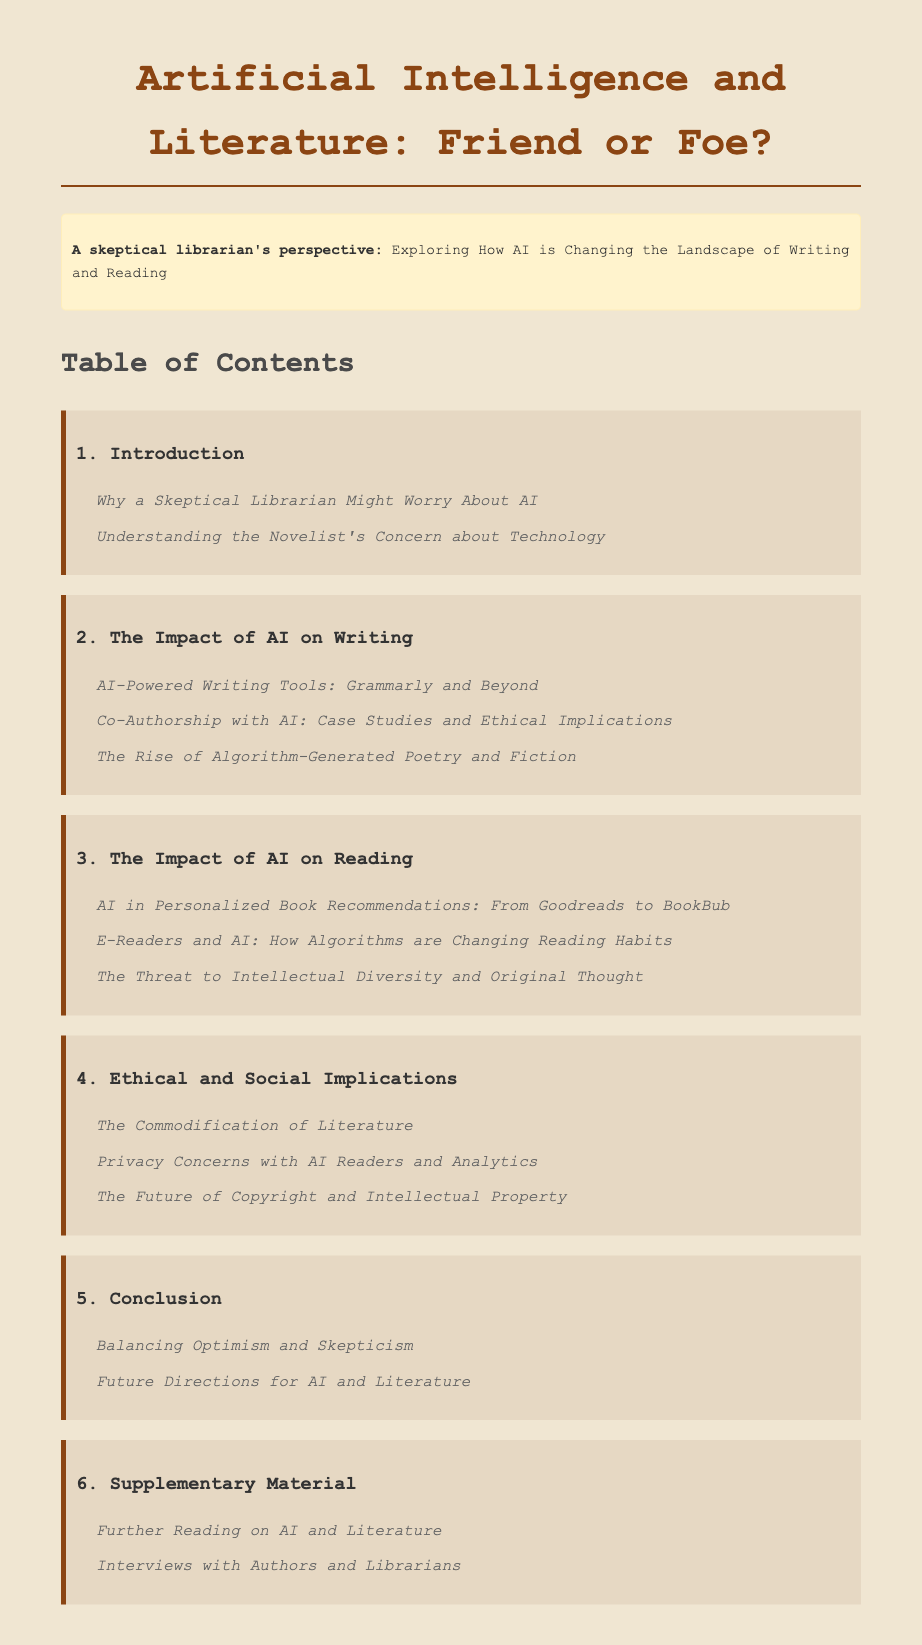What is the title of the document? The title is presented prominently at the top of the document, identifying the main topic.
Answer: Artificial Intelligence and Literature: Friend or Foe? What is the first subchapter listed under "Introduction"? The first subchapter of the first chapter, "Introduction," is explicitly listed after the chapter title.
Answer: Why a Skeptical Librarian Might Worry About AI How many subchapters are under "The Impact of AI on Writing"? The document lists how many topics are discussed under this chapter, which can be counted.
Answer: Three What ethical concern is discussed in the "Ethical and Social Implications" chapter? A specific concern mentioned in the subchapters indicates a broader issue related to literature and AI.
Answer: The Commodification of Literature What chapter discusses the future of copyright? The chapter dedicated to discussing legal implications provides insights into copyright issues related to AI.
Answer: Ethical and Social Implications How many chapters are in the document? The number of chapters is identifiable by counting the main sections presented in the table of contents.
Answer: Six What is the last subchapter in the document? The last subchapter is the final title listed in the supplementary materials section of the table of contents.
Answer: Interviews with Authors and Librarians Which chapter contains information on AI in personalized book recommendations? The specific chapter is titled in a way that makes the topic of book recommendations clear.
Answer: The Impact of AI on Reading What chapter includes a discussion on privacy concerns? The mention of privacy relates to the implications of using AI in literature, found in the respective chapter.
Answer: Ethical and Social Implications 